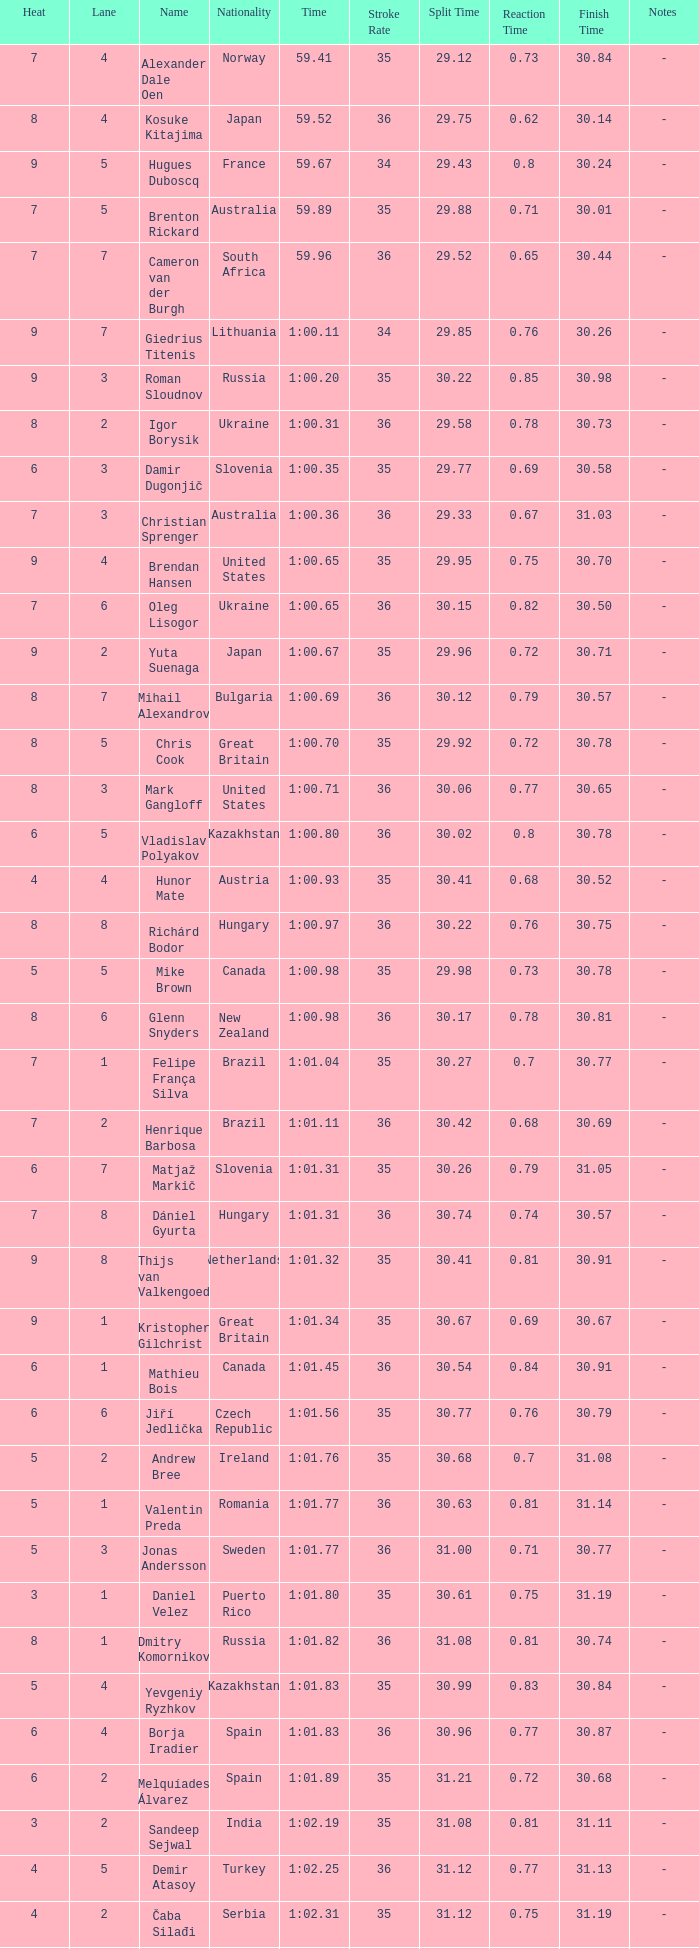What is the time in a heat smaller than 5, in Lane 5, for Vietnam? 1:06.36. 